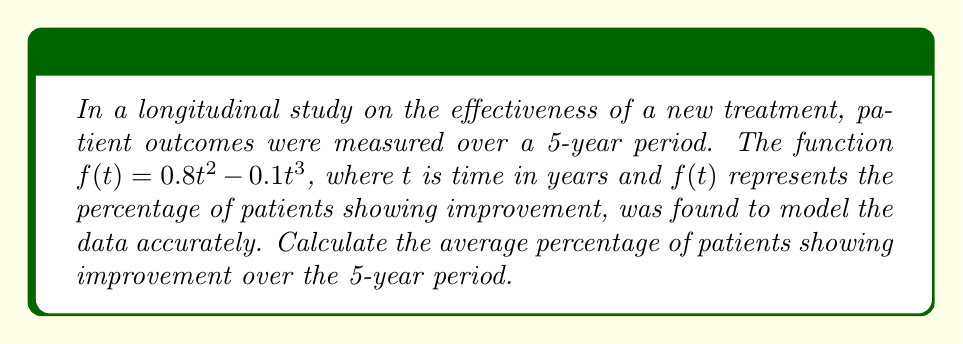Help me with this question. To solve this problem, we need to follow these steps:

1) The average value of a function over an interval is given by the definite integral of the function divided by the length of the interval. In this case:

   Average = $\frac{1}{5-0} \int_0^5 f(t) dt$

2) We need to calculate $\int_0^5 (0.8t^2 - 0.1t^3) dt$

3) Integrate the function:
   
   $\int (0.8t^2 - 0.1t^3) dt = 0.8 \cdot \frac{t^3}{3} - 0.1 \cdot \frac{t^4}{4} + C$

4) Apply the limits:

   $[\frac{0.8t^3}{3} - \frac{0.1t^4}{4}]_0^5$

5) Evaluate:

   $(\frac{0.8 \cdot 5^3}{3} - \frac{0.1 \cdot 5^4}{4}) - (0 - 0)$
   
   $= \frac{0.8 \cdot 125}{3} - \frac{0.1 \cdot 625}{4}$
   
   $= 33.33333 - 15.625 = 17.70833$

6) Divide by the interval length (5 years):

   $\frac{17.70833}{5} = 3.54167$

Therefore, the average percentage of patients showing improvement over the 5-year period is approximately 3.54%.
Answer: 3.54% 